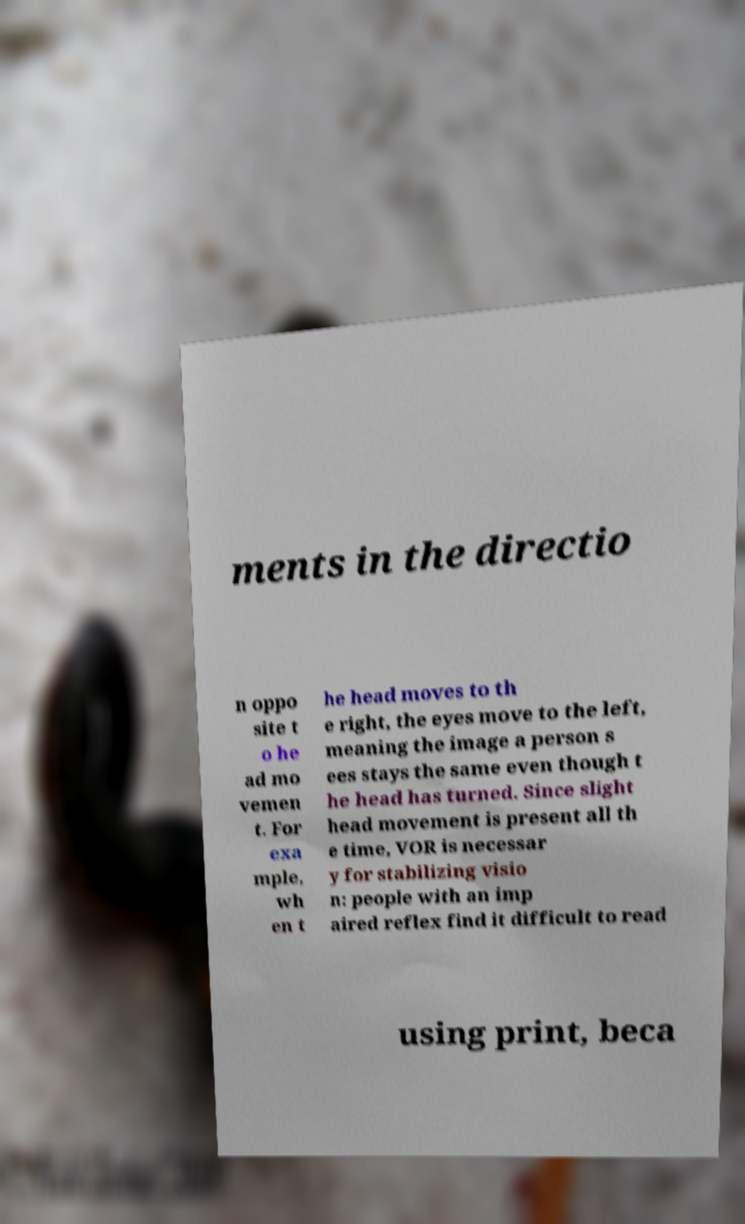Can you accurately transcribe the text from the provided image for me? ments in the directio n oppo site t o he ad mo vemen t. For exa mple, wh en t he head moves to th e right, the eyes move to the left, meaning the image a person s ees stays the same even though t he head has turned. Since slight head movement is present all th e time, VOR is necessar y for stabilizing visio n: people with an imp aired reflex find it difficult to read using print, beca 